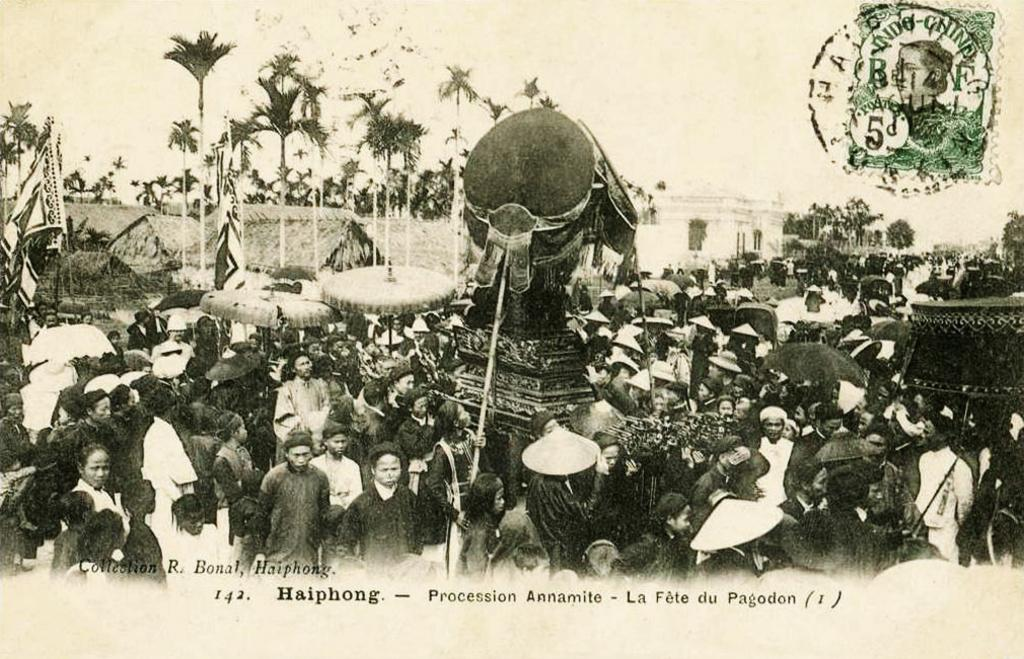What is the color scheme of the image? The image is black and white. How many people are present in the image? There are many people in the image. What is one of the prominent features in the image? There is a statue in the image. What can be seen flying in the image? There are flags in the image. What are the tall, vertical structures in the image? There are poles in the image. What type of natural elements are present in the image? There are trees in the image. What type of man-made structures can be seen in the image? There are buildings in the image. What can be used for protection from the sun or rain in the image? There are umbrellas in the image. What type of education is being provided to the people in the image? There is no indication of education or any learning activity in the image. 